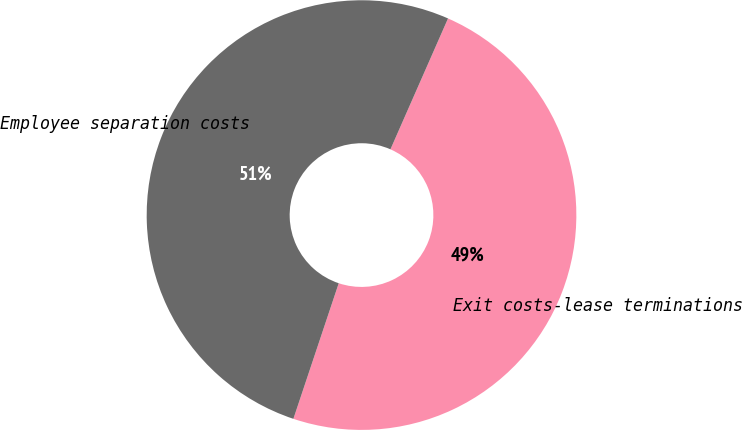<chart> <loc_0><loc_0><loc_500><loc_500><pie_chart><fcel>Exit costs-lease terminations<fcel>Employee separation costs<nl><fcel>48.54%<fcel>51.46%<nl></chart> 